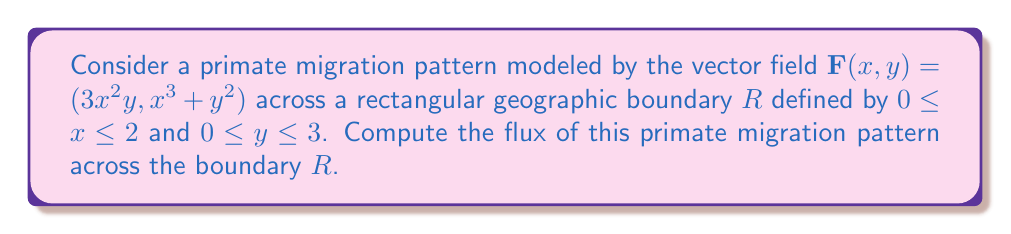Can you answer this question? To compute the flux of the vector field $\mathbf{F}(x,y)$ across the rectangular boundary $R$, we'll use Green's theorem, which relates a line integral around a simple closed curve to a double integral over the plane region it encloses.

Green's theorem states:

$$\oint_C (P dx + Q dy) = \iint_R (\frac{\partial Q}{\partial x} - \frac{\partial P}{\partial y}) dA$$

Where $\mathbf{F}(x,y) = (P(x,y), Q(x,y))$.

Step 1: Identify $P(x,y)$ and $Q(x,y)$
$P(x,y) = 3x^2y$
$Q(x,y) = x^3 + y^2$

Step 2: Calculate partial derivatives
$\frac{\partial Q}{\partial x} = 3x^2$
$\frac{\partial P}{\partial y} = 3x^2$

Step 3: Compute $\frac{\partial Q}{\partial x} - \frac{\partial P}{\partial y}$
$\frac{\partial Q}{\partial x} - \frac{\partial P}{\partial y} = 3x^2 - 3x^2 = 0$

Step 4: Set up the double integral
$$\text{Flux} = \iint_R (\frac{\partial Q}{\partial x} - \frac{\partial P}{\partial y}) dA = \int_0^3 \int_0^2 0 \, dx \, dy$$

Step 5: Evaluate the integral
Since the integrand is zero, the flux is zero regardless of the limits of integration.

$$\text{Flux} = 0$$

This result indicates that there is no net flow of primates across the boundary $R$, suggesting a balanced migration pattern in this model.
Answer: 0 